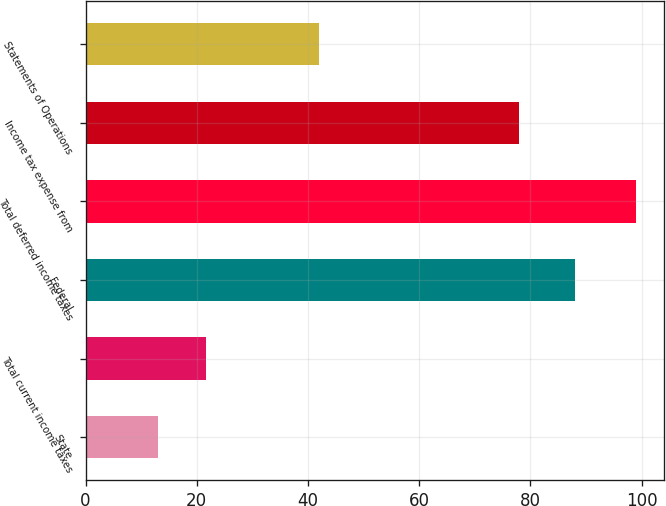Convert chart. <chart><loc_0><loc_0><loc_500><loc_500><bar_chart><fcel>State<fcel>Total current income taxes<fcel>Federal<fcel>Total deferred income taxes<fcel>Income tax expense from<fcel>Statements of Operations<nl><fcel>13<fcel>21.6<fcel>88<fcel>99<fcel>78<fcel>42<nl></chart> 